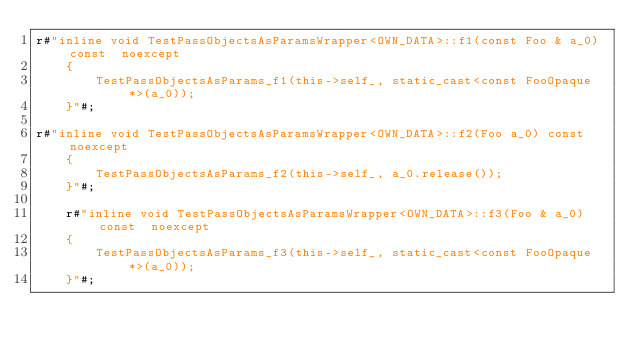<code> <loc_0><loc_0><loc_500><loc_500><_C++_>r#"inline void TestPassObjectsAsParamsWrapper<OWN_DATA>::f1(const Foo & a_0) const  noexcept
    {
        TestPassObjectsAsParams_f1(this->self_, static_cast<const FooOpaque *>(a_0));
    }"#;
    
r#"inline void TestPassObjectsAsParamsWrapper<OWN_DATA>::f2(Foo a_0) const  noexcept
    {
        TestPassObjectsAsParams_f2(this->self_, a_0.release());
    }"#;
    
    r#"inline void TestPassObjectsAsParamsWrapper<OWN_DATA>::f3(Foo & a_0) const  noexcept
    {
        TestPassObjectsAsParams_f3(this->self_, static_cast<const FooOpaque *>(a_0));
    }"#;
</code> 